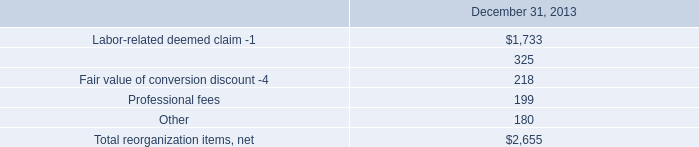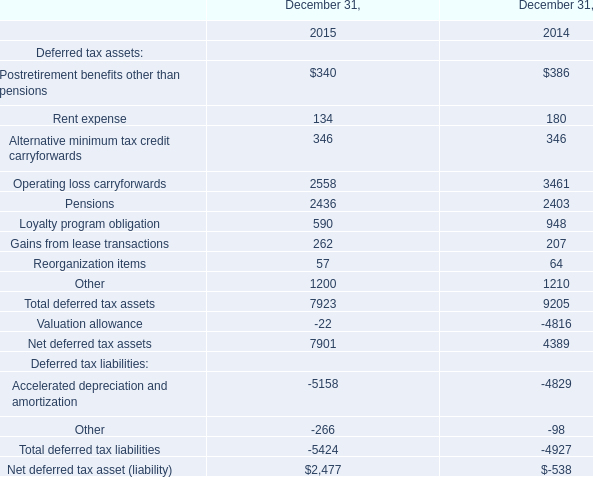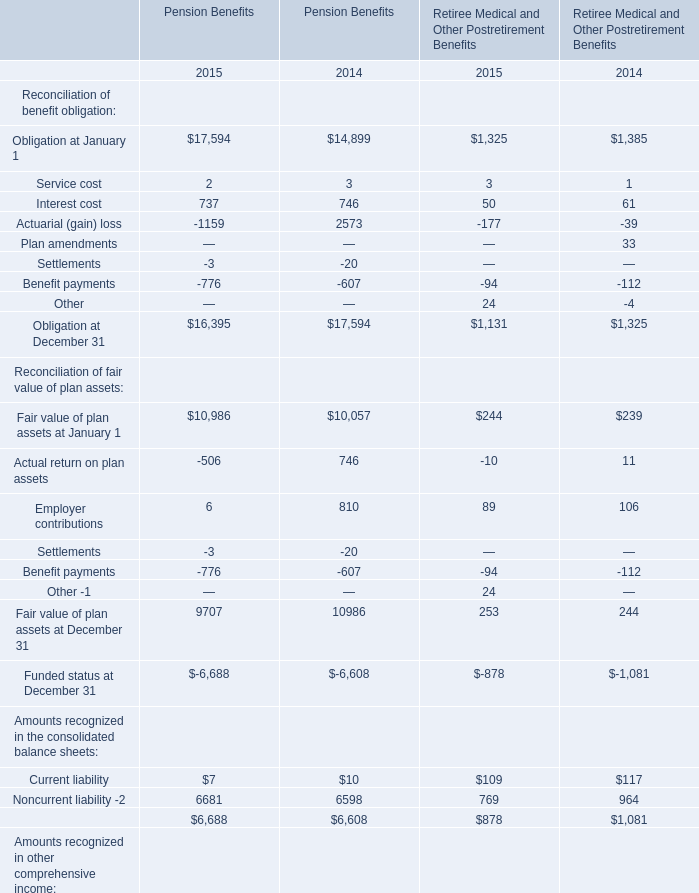What's the average of Interest cost in 2014 and 2015? 
Computations: (((737 + 746) + (50 + 61)) / 4)
Answer: 398.5. 